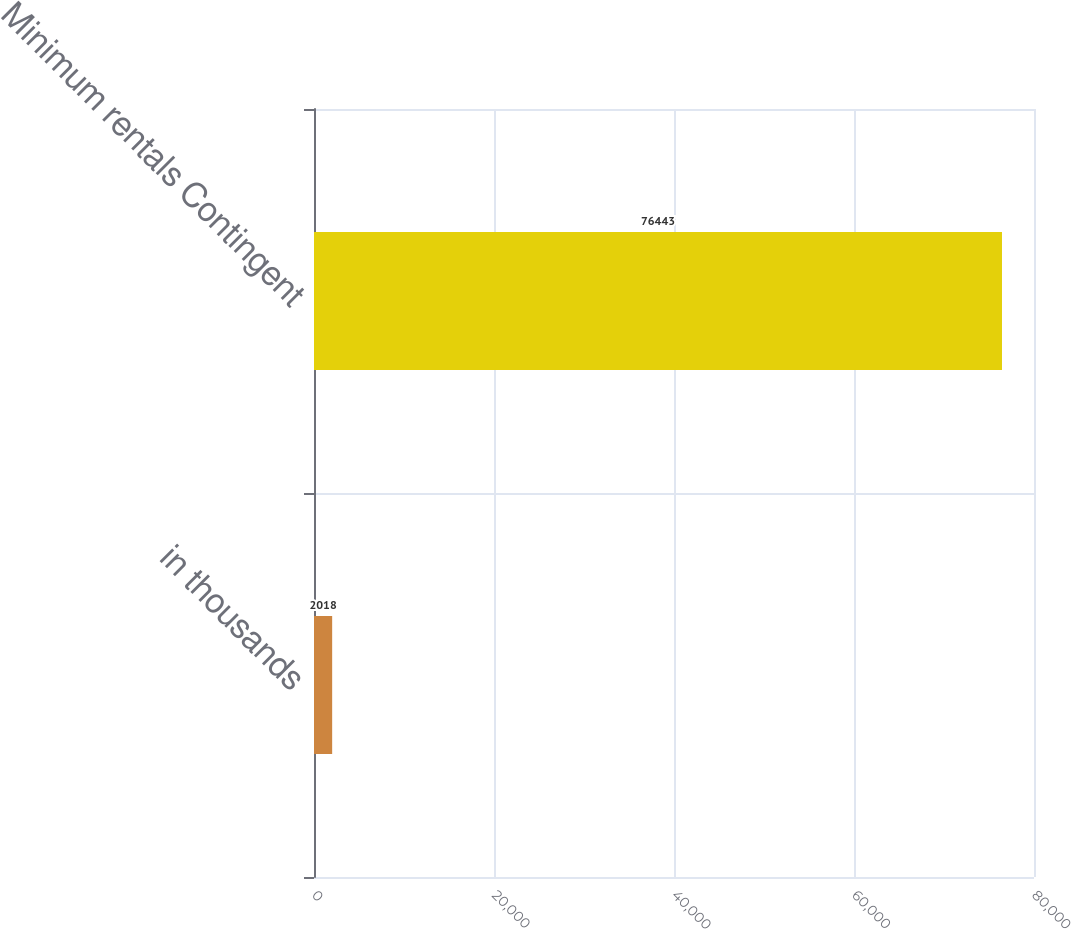Convert chart to OTSL. <chart><loc_0><loc_0><loc_500><loc_500><bar_chart><fcel>in thousands<fcel>Minimum rentals Contingent<nl><fcel>2018<fcel>76443<nl></chart> 